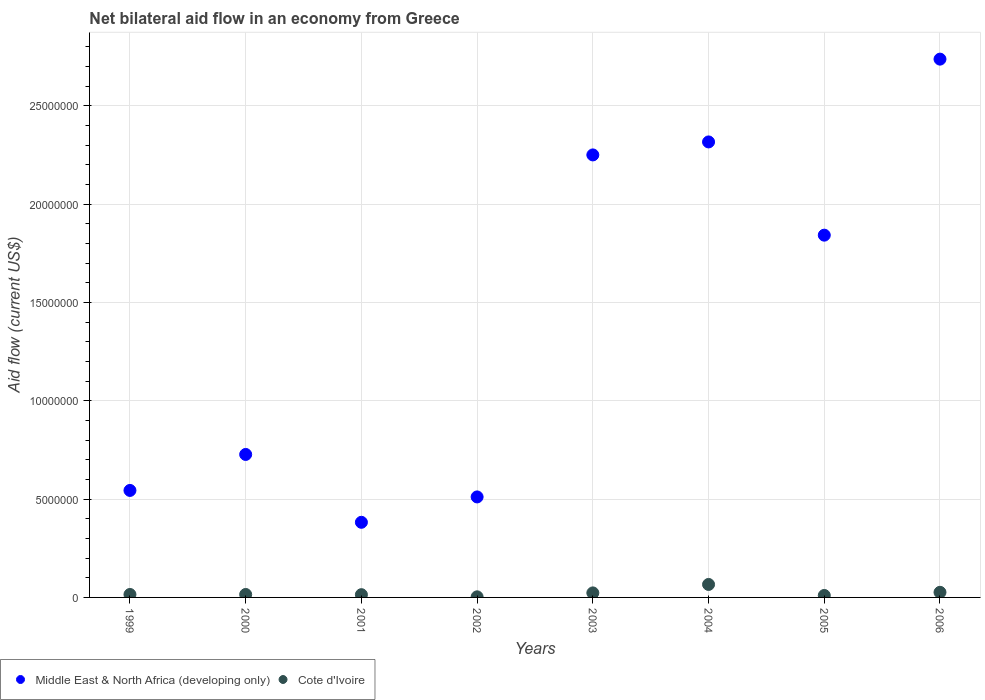How many different coloured dotlines are there?
Your response must be concise. 2. What is the net bilateral aid flow in Cote d'Ivoire in 2001?
Your answer should be very brief. 1.40e+05. Across all years, what is the maximum net bilateral aid flow in Middle East & North Africa (developing only)?
Your answer should be compact. 2.74e+07. Across all years, what is the minimum net bilateral aid flow in Cote d'Ivoire?
Keep it short and to the point. 3.00e+04. What is the total net bilateral aid flow in Cote d'Ivoire in the graph?
Keep it short and to the point. 1.72e+06. What is the difference between the net bilateral aid flow in Middle East & North Africa (developing only) in 2003 and the net bilateral aid flow in Cote d'Ivoire in 1999?
Your response must be concise. 2.24e+07. What is the average net bilateral aid flow in Cote d'Ivoire per year?
Provide a short and direct response. 2.15e+05. In the year 2000, what is the difference between the net bilateral aid flow in Cote d'Ivoire and net bilateral aid flow in Middle East & North Africa (developing only)?
Your answer should be compact. -7.12e+06. What is the ratio of the net bilateral aid flow in Middle East & North Africa (developing only) in 2004 to that in 2005?
Offer a terse response. 1.26. Is the net bilateral aid flow in Middle East & North Africa (developing only) in 1999 less than that in 2000?
Offer a very short reply. Yes. Is the difference between the net bilateral aid flow in Cote d'Ivoire in 2000 and 2003 greater than the difference between the net bilateral aid flow in Middle East & North Africa (developing only) in 2000 and 2003?
Make the answer very short. Yes. What is the difference between the highest and the lowest net bilateral aid flow in Middle East & North Africa (developing only)?
Provide a short and direct response. 2.36e+07. Does the net bilateral aid flow in Cote d'Ivoire monotonically increase over the years?
Keep it short and to the point. No. Is the net bilateral aid flow in Middle East & North Africa (developing only) strictly greater than the net bilateral aid flow in Cote d'Ivoire over the years?
Your answer should be very brief. Yes. Is the net bilateral aid flow in Cote d'Ivoire strictly less than the net bilateral aid flow in Middle East & North Africa (developing only) over the years?
Ensure brevity in your answer.  Yes. How many dotlines are there?
Offer a terse response. 2. What is the difference between two consecutive major ticks on the Y-axis?
Provide a succinct answer. 5.00e+06. Does the graph contain any zero values?
Keep it short and to the point. No. How are the legend labels stacked?
Give a very brief answer. Horizontal. What is the title of the graph?
Offer a terse response. Net bilateral aid flow in an economy from Greece. Does "Sub-Saharan Africa (developing only)" appear as one of the legend labels in the graph?
Provide a succinct answer. No. What is the label or title of the X-axis?
Keep it short and to the point. Years. What is the Aid flow (current US$) of Middle East & North Africa (developing only) in 1999?
Offer a terse response. 5.44e+06. What is the Aid flow (current US$) of Middle East & North Africa (developing only) in 2000?
Provide a short and direct response. 7.27e+06. What is the Aid flow (current US$) in Middle East & North Africa (developing only) in 2001?
Give a very brief answer. 3.82e+06. What is the Aid flow (current US$) of Middle East & North Africa (developing only) in 2002?
Keep it short and to the point. 5.11e+06. What is the Aid flow (current US$) in Cote d'Ivoire in 2002?
Give a very brief answer. 3.00e+04. What is the Aid flow (current US$) of Middle East & North Africa (developing only) in 2003?
Give a very brief answer. 2.25e+07. What is the Aid flow (current US$) of Cote d'Ivoire in 2003?
Your answer should be compact. 2.30e+05. What is the Aid flow (current US$) in Middle East & North Africa (developing only) in 2004?
Your answer should be compact. 2.32e+07. What is the Aid flow (current US$) of Middle East & North Africa (developing only) in 2005?
Your answer should be compact. 1.84e+07. What is the Aid flow (current US$) of Cote d'Ivoire in 2005?
Provide a succinct answer. 1.00e+05. What is the Aid flow (current US$) of Middle East & North Africa (developing only) in 2006?
Your response must be concise. 2.74e+07. Across all years, what is the maximum Aid flow (current US$) in Middle East & North Africa (developing only)?
Offer a terse response. 2.74e+07. Across all years, what is the maximum Aid flow (current US$) in Cote d'Ivoire?
Your answer should be compact. 6.60e+05. Across all years, what is the minimum Aid flow (current US$) in Middle East & North Africa (developing only)?
Your response must be concise. 3.82e+06. What is the total Aid flow (current US$) of Middle East & North Africa (developing only) in the graph?
Give a very brief answer. 1.13e+08. What is the total Aid flow (current US$) in Cote d'Ivoire in the graph?
Keep it short and to the point. 1.72e+06. What is the difference between the Aid flow (current US$) of Middle East & North Africa (developing only) in 1999 and that in 2000?
Keep it short and to the point. -1.83e+06. What is the difference between the Aid flow (current US$) of Cote d'Ivoire in 1999 and that in 2000?
Provide a short and direct response. 0. What is the difference between the Aid flow (current US$) in Middle East & North Africa (developing only) in 1999 and that in 2001?
Provide a short and direct response. 1.62e+06. What is the difference between the Aid flow (current US$) of Cote d'Ivoire in 1999 and that in 2001?
Your answer should be very brief. 10000. What is the difference between the Aid flow (current US$) in Middle East & North Africa (developing only) in 1999 and that in 2002?
Provide a succinct answer. 3.30e+05. What is the difference between the Aid flow (current US$) of Middle East & North Africa (developing only) in 1999 and that in 2003?
Provide a succinct answer. -1.71e+07. What is the difference between the Aid flow (current US$) of Cote d'Ivoire in 1999 and that in 2003?
Keep it short and to the point. -8.00e+04. What is the difference between the Aid flow (current US$) of Middle East & North Africa (developing only) in 1999 and that in 2004?
Provide a succinct answer. -1.77e+07. What is the difference between the Aid flow (current US$) in Cote d'Ivoire in 1999 and that in 2004?
Offer a terse response. -5.10e+05. What is the difference between the Aid flow (current US$) of Middle East & North Africa (developing only) in 1999 and that in 2005?
Ensure brevity in your answer.  -1.30e+07. What is the difference between the Aid flow (current US$) in Cote d'Ivoire in 1999 and that in 2005?
Provide a short and direct response. 5.00e+04. What is the difference between the Aid flow (current US$) in Middle East & North Africa (developing only) in 1999 and that in 2006?
Give a very brief answer. -2.19e+07. What is the difference between the Aid flow (current US$) of Cote d'Ivoire in 1999 and that in 2006?
Offer a terse response. -1.10e+05. What is the difference between the Aid flow (current US$) of Middle East & North Africa (developing only) in 2000 and that in 2001?
Give a very brief answer. 3.45e+06. What is the difference between the Aid flow (current US$) in Middle East & North Africa (developing only) in 2000 and that in 2002?
Offer a very short reply. 2.16e+06. What is the difference between the Aid flow (current US$) of Middle East & North Africa (developing only) in 2000 and that in 2003?
Make the answer very short. -1.52e+07. What is the difference between the Aid flow (current US$) in Middle East & North Africa (developing only) in 2000 and that in 2004?
Offer a terse response. -1.59e+07. What is the difference between the Aid flow (current US$) in Cote d'Ivoire in 2000 and that in 2004?
Provide a succinct answer. -5.10e+05. What is the difference between the Aid flow (current US$) in Middle East & North Africa (developing only) in 2000 and that in 2005?
Provide a succinct answer. -1.12e+07. What is the difference between the Aid flow (current US$) of Middle East & North Africa (developing only) in 2000 and that in 2006?
Offer a terse response. -2.01e+07. What is the difference between the Aid flow (current US$) in Middle East & North Africa (developing only) in 2001 and that in 2002?
Give a very brief answer. -1.29e+06. What is the difference between the Aid flow (current US$) of Cote d'Ivoire in 2001 and that in 2002?
Your response must be concise. 1.10e+05. What is the difference between the Aid flow (current US$) of Middle East & North Africa (developing only) in 2001 and that in 2003?
Make the answer very short. -1.87e+07. What is the difference between the Aid flow (current US$) of Cote d'Ivoire in 2001 and that in 2003?
Give a very brief answer. -9.00e+04. What is the difference between the Aid flow (current US$) of Middle East & North Africa (developing only) in 2001 and that in 2004?
Keep it short and to the point. -1.93e+07. What is the difference between the Aid flow (current US$) in Cote d'Ivoire in 2001 and that in 2004?
Make the answer very short. -5.20e+05. What is the difference between the Aid flow (current US$) of Middle East & North Africa (developing only) in 2001 and that in 2005?
Offer a very short reply. -1.46e+07. What is the difference between the Aid flow (current US$) in Cote d'Ivoire in 2001 and that in 2005?
Ensure brevity in your answer.  4.00e+04. What is the difference between the Aid flow (current US$) of Middle East & North Africa (developing only) in 2001 and that in 2006?
Your answer should be compact. -2.36e+07. What is the difference between the Aid flow (current US$) in Cote d'Ivoire in 2001 and that in 2006?
Your answer should be very brief. -1.20e+05. What is the difference between the Aid flow (current US$) of Middle East & North Africa (developing only) in 2002 and that in 2003?
Keep it short and to the point. -1.74e+07. What is the difference between the Aid flow (current US$) in Cote d'Ivoire in 2002 and that in 2003?
Provide a succinct answer. -2.00e+05. What is the difference between the Aid flow (current US$) of Middle East & North Africa (developing only) in 2002 and that in 2004?
Make the answer very short. -1.80e+07. What is the difference between the Aid flow (current US$) in Cote d'Ivoire in 2002 and that in 2004?
Make the answer very short. -6.30e+05. What is the difference between the Aid flow (current US$) of Middle East & North Africa (developing only) in 2002 and that in 2005?
Provide a succinct answer. -1.33e+07. What is the difference between the Aid flow (current US$) in Cote d'Ivoire in 2002 and that in 2005?
Make the answer very short. -7.00e+04. What is the difference between the Aid flow (current US$) in Middle East & North Africa (developing only) in 2002 and that in 2006?
Your answer should be compact. -2.23e+07. What is the difference between the Aid flow (current US$) in Cote d'Ivoire in 2002 and that in 2006?
Offer a terse response. -2.30e+05. What is the difference between the Aid flow (current US$) of Middle East & North Africa (developing only) in 2003 and that in 2004?
Ensure brevity in your answer.  -6.60e+05. What is the difference between the Aid flow (current US$) of Cote d'Ivoire in 2003 and that in 2004?
Offer a terse response. -4.30e+05. What is the difference between the Aid flow (current US$) in Middle East & North Africa (developing only) in 2003 and that in 2005?
Your response must be concise. 4.08e+06. What is the difference between the Aid flow (current US$) of Middle East & North Africa (developing only) in 2003 and that in 2006?
Keep it short and to the point. -4.87e+06. What is the difference between the Aid flow (current US$) of Cote d'Ivoire in 2003 and that in 2006?
Keep it short and to the point. -3.00e+04. What is the difference between the Aid flow (current US$) of Middle East & North Africa (developing only) in 2004 and that in 2005?
Your response must be concise. 4.74e+06. What is the difference between the Aid flow (current US$) in Cote d'Ivoire in 2004 and that in 2005?
Provide a succinct answer. 5.60e+05. What is the difference between the Aid flow (current US$) in Middle East & North Africa (developing only) in 2004 and that in 2006?
Provide a short and direct response. -4.21e+06. What is the difference between the Aid flow (current US$) of Middle East & North Africa (developing only) in 2005 and that in 2006?
Keep it short and to the point. -8.95e+06. What is the difference between the Aid flow (current US$) in Cote d'Ivoire in 2005 and that in 2006?
Keep it short and to the point. -1.60e+05. What is the difference between the Aid flow (current US$) in Middle East & North Africa (developing only) in 1999 and the Aid flow (current US$) in Cote d'Ivoire in 2000?
Your response must be concise. 5.29e+06. What is the difference between the Aid flow (current US$) in Middle East & North Africa (developing only) in 1999 and the Aid flow (current US$) in Cote d'Ivoire in 2001?
Your answer should be compact. 5.30e+06. What is the difference between the Aid flow (current US$) of Middle East & North Africa (developing only) in 1999 and the Aid flow (current US$) of Cote d'Ivoire in 2002?
Offer a very short reply. 5.41e+06. What is the difference between the Aid flow (current US$) in Middle East & North Africa (developing only) in 1999 and the Aid flow (current US$) in Cote d'Ivoire in 2003?
Your answer should be very brief. 5.21e+06. What is the difference between the Aid flow (current US$) of Middle East & North Africa (developing only) in 1999 and the Aid flow (current US$) of Cote d'Ivoire in 2004?
Give a very brief answer. 4.78e+06. What is the difference between the Aid flow (current US$) in Middle East & North Africa (developing only) in 1999 and the Aid flow (current US$) in Cote d'Ivoire in 2005?
Keep it short and to the point. 5.34e+06. What is the difference between the Aid flow (current US$) in Middle East & North Africa (developing only) in 1999 and the Aid flow (current US$) in Cote d'Ivoire in 2006?
Provide a short and direct response. 5.18e+06. What is the difference between the Aid flow (current US$) of Middle East & North Africa (developing only) in 2000 and the Aid flow (current US$) of Cote d'Ivoire in 2001?
Your answer should be very brief. 7.13e+06. What is the difference between the Aid flow (current US$) in Middle East & North Africa (developing only) in 2000 and the Aid flow (current US$) in Cote d'Ivoire in 2002?
Your answer should be very brief. 7.24e+06. What is the difference between the Aid flow (current US$) in Middle East & North Africa (developing only) in 2000 and the Aid flow (current US$) in Cote d'Ivoire in 2003?
Provide a succinct answer. 7.04e+06. What is the difference between the Aid flow (current US$) of Middle East & North Africa (developing only) in 2000 and the Aid flow (current US$) of Cote d'Ivoire in 2004?
Offer a very short reply. 6.61e+06. What is the difference between the Aid flow (current US$) in Middle East & North Africa (developing only) in 2000 and the Aid flow (current US$) in Cote d'Ivoire in 2005?
Your answer should be very brief. 7.17e+06. What is the difference between the Aid flow (current US$) of Middle East & North Africa (developing only) in 2000 and the Aid flow (current US$) of Cote d'Ivoire in 2006?
Provide a short and direct response. 7.01e+06. What is the difference between the Aid flow (current US$) of Middle East & North Africa (developing only) in 2001 and the Aid flow (current US$) of Cote d'Ivoire in 2002?
Keep it short and to the point. 3.79e+06. What is the difference between the Aid flow (current US$) of Middle East & North Africa (developing only) in 2001 and the Aid flow (current US$) of Cote d'Ivoire in 2003?
Provide a succinct answer. 3.59e+06. What is the difference between the Aid flow (current US$) of Middle East & North Africa (developing only) in 2001 and the Aid flow (current US$) of Cote d'Ivoire in 2004?
Your answer should be compact. 3.16e+06. What is the difference between the Aid flow (current US$) of Middle East & North Africa (developing only) in 2001 and the Aid flow (current US$) of Cote d'Ivoire in 2005?
Your answer should be very brief. 3.72e+06. What is the difference between the Aid flow (current US$) of Middle East & North Africa (developing only) in 2001 and the Aid flow (current US$) of Cote d'Ivoire in 2006?
Provide a short and direct response. 3.56e+06. What is the difference between the Aid flow (current US$) of Middle East & North Africa (developing only) in 2002 and the Aid flow (current US$) of Cote d'Ivoire in 2003?
Your answer should be very brief. 4.88e+06. What is the difference between the Aid flow (current US$) in Middle East & North Africa (developing only) in 2002 and the Aid flow (current US$) in Cote d'Ivoire in 2004?
Your answer should be very brief. 4.45e+06. What is the difference between the Aid flow (current US$) of Middle East & North Africa (developing only) in 2002 and the Aid flow (current US$) of Cote d'Ivoire in 2005?
Offer a very short reply. 5.01e+06. What is the difference between the Aid flow (current US$) in Middle East & North Africa (developing only) in 2002 and the Aid flow (current US$) in Cote d'Ivoire in 2006?
Make the answer very short. 4.85e+06. What is the difference between the Aid flow (current US$) in Middle East & North Africa (developing only) in 2003 and the Aid flow (current US$) in Cote d'Ivoire in 2004?
Keep it short and to the point. 2.18e+07. What is the difference between the Aid flow (current US$) of Middle East & North Africa (developing only) in 2003 and the Aid flow (current US$) of Cote d'Ivoire in 2005?
Ensure brevity in your answer.  2.24e+07. What is the difference between the Aid flow (current US$) of Middle East & North Africa (developing only) in 2003 and the Aid flow (current US$) of Cote d'Ivoire in 2006?
Offer a terse response. 2.22e+07. What is the difference between the Aid flow (current US$) in Middle East & North Africa (developing only) in 2004 and the Aid flow (current US$) in Cote d'Ivoire in 2005?
Offer a very short reply. 2.31e+07. What is the difference between the Aid flow (current US$) of Middle East & North Africa (developing only) in 2004 and the Aid flow (current US$) of Cote d'Ivoire in 2006?
Give a very brief answer. 2.29e+07. What is the difference between the Aid flow (current US$) in Middle East & North Africa (developing only) in 2005 and the Aid flow (current US$) in Cote d'Ivoire in 2006?
Your response must be concise. 1.82e+07. What is the average Aid flow (current US$) of Middle East & North Africa (developing only) per year?
Offer a terse response. 1.41e+07. What is the average Aid flow (current US$) in Cote d'Ivoire per year?
Ensure brevity in your answer.  2.15e+05. In the year 1999, what is the difference between the Aid flow (current US$) of Middle East & North Africa (developing only) and Aid flow (current US$) of Cote d'Ivoire?
Offer a very short reply. 5.29e+06. In the year 2000, what is the difference between the Aid flow (current US$) of Middle East & North Africa (developing only) and Aid flow (current US$) of Cote d'Ivoire?
Keep it short and to the point. 7.12e+06. In the year 2001, what is the difference between the Aid flow (current US$) in Middle East & North Africa (developing only) and Aid flow (current US$) in Cote d'Ivoire?
Keep it short and to the point. 3.68e+06. In the year 2002, what is the difference between the Aid flow (current US$) of Middle East & North Africa (developing only) and Aid flow (current US$) of Cote d'Ivoire?
Offer a terse response. 5.08e+06. In the year 2003, what is the difference between the Aid flow (current US$) in Middle East & North Africa (developing only) and Aid flow (current US$) in Cote d'Ivoire?
Your answer should be compact. 2.23e+07. In the year 2004, what is the difference between the Aid flow (current US$) in Middle East & North Africa (developing only) and Aid flow (current US$) in Cote d'Ivoire?
Keep it short and to the point. 2.25e+07. In the year 2005, what is the difference between the Aid flow (current US$) of Middle East & North Africa (developing only) and Aid flow (current US$) of Cote d'Ivoire?
Your answer should be compact. 1.83e+07. In the year 2006, what is the difference between the Aid flow (current US$) in Middle East & North Africa (developing only) and Aid flow (current US$) in Cote d'Ivoire?
Make the answer very short. 2.71e+07. What is the ratio of the Aid flow (current US$) in Middle East & North Africa (developing only) in 1999 to that in 2000?
Keep it short and to the point. 0.75. What is the ratio of the Aid flow (current US$) in Middle East & North Africa (developing only) in 1999 to that in 2001?
Your response must be concise. 1.42. What is the ratio of the Aid flow (current US$) of Cote d'Ivoire in 1999 to that in 2001?
Keep it short and to the point. 1.07. What is the ratio of the Aid flow (current US$) in Middle East & North Africa (developing only) in 1999 to that in 2002?
Provide a succinct answer. 1.06. What is the ratio of the Aid flow (current US$) in Middle East & North Africa (developing only) in 1999 to that in 2003?
Provide a succinct answer. 0.24. What is the ratio of the Aid flow (current US$) in Cote d'Ivoire in 1999 to that in 2003?
Provide a short and direct response. 0.65. What is the ratio of the Aid flow (current US$) in Middle East & North Africa (developing only) in 1999 to that in 2004?
Offer a very short reply. 0.23. What is the ratio of the Aid flow (current US$) in Cote d'Ivoire in 1999 to that in 2004?
Your answer should be very brief. 0.23. What is the ratio of the Aid flow (current US$) of Middle East & North Africa (developing only) in 1999 to that in 2005?
Keep it short and to the point. 0.3. What is the ratio of the Aid flow (current US$) of Middle East & North Africa (developing only) in 1999 to that in 2006?
Provide a short and direct response. 0.2. What is the ratio of the Aid flow (current US$) of Cote d'Ivoire in 1999 to that in 2006?
Your response must be concise. 0.58. What is the ratio of the Aid flow (current US$) of Middle East & North Africa (developing only) in 2000 to that in 2001?
Provide a short and direct response. 1.9. What is the ratio of the Aid flow (current US$) in Cote d'Ivoire in 2000 to that in 2001?
Your response must be concise. 1.07. What is the ratio of the Aid flow (current US$) of Middle East & North Africa (developing only) in 2000 to that in 2002?
Offer a very short reply. 1.42. What is the ratio of the Aid flow (current US$) of Middle East & North Africa (developing only) in 2000 to that in 2003?
Offer a very short reply. 0.32. What is the ratio of the Aid flow (current US$) in Cote d'Ivoire in 2000 to that in 2003?
Offer a terse response. 0.65. What is the ratio of the Aid flow (current US$) of Middle East & North Africa (developing only) in 2000 to that in 2004?
Ensure brevity in your answer.  0.31. What is the ratio of the Aid flow (current US$) of Cote d'Ivoire in 2000 to that in 2004?
Ensure brevity in your answer.  0.23. What is the ratio of the Aid flow (current US$) of Middle East & North Africa (developing only) in 2000 to that in 2005?
Offer a very short reply. 0.39. What is the ratio of the Aid flow (current US$) of Cote d'Ivoire in 2000 to that in 2005?
Give a very brief answer. 1.5. What is the ratio of the Aid flow (current US$) of Middle East & North Africa (developing only) in 2000 to that in 2006?
Provide a succinct answer. 0.27. What is the ratio of the Aid flow (current US$) of Cote d'Ivoire in 2000 to that in 2006?
Your answer should be very brief. 0.58. What is the ratio of the Aid flow (current US$) of Middle East & North Africa (developing only) in 2001 to that in 2002?
Give a very brief answer. 0.75. What is the ratio of the Aid flow (current US$) of Cote d'Ivoire in 2001 to that in 2002?
Provide a short and direct response. 4.67. What is the ratio of the Aid flow (current US$) in Middle East & North Africa (developing only) in 2001 to that in 2003?
Keep it short and to the point. 0.17. What is the ratio of the Aid flow (current US$) of Cote d'Ivoire in 2001 to that in 2003?
Your response must be concise. 0.61. What is the ratio of the Aid flow (current US$) in Middle East & North Africa (developing only) in 2001 to that in 2004?
Make the answer very short. 0.16. What is the ratio of the Aid flow (current US$) of Cote d'Ivoire in 2001 to that in 2004?
Ensure brevity in your answer.  0.21. What is the ratio of the Aid flow (current US$) in Middle East & North Africa (developing only) in 2001 to that in 2005?
Your answer should be compact. 0.21. What is the ratio of the Aid flow (current US$) in Cote d'Ivoire in 2001 to that in 2005?
Provide a short and direct response. 1.4. What is the ratio of the Aid flow (current US$) of Middle East & North Africa (developing only) in 2001 to that in 2006?
Provide a succinct answer. 0.14. What is the ratio of the Aid flow (current US$) in Cote d'Ivoire in 2001 to that in 2006?
Make the answer very short. 0.54. What is the ratio of the Aid flow (current US$) of Middle East & North Africa (developing only) in 2002 to that in 2003?
Your response must be concise. 0.23. What is the ratio of the Aid flow (current US$) in Cote d'Ivoire in 2002 to that in 2003?
Keep it short and to the point. 0.13. What is the ratio of the Aid flow (current US$) of Middle East & North Africa (developing only) in 2002 to that in 2004?
Give a very brief answer. 0.22. What is the ratio of the Aid flow (current US$) of Cote d'Ivoire in 2002 to that in 2004?
Your answer should be very brief. 0.05. What is the ratio of the Aid flow (current US$) in Middle East & North Africa (developing only) in 2002 to that in 2005?
Your answer should be very brief. 0.28. What is the ratio of the Aid flow (current US$) in Cote d'Ivoire in 2002 to that in 2005?
Your response must be concise. 0.3. What is the ratio of the Aid flow (current US$) of Middle East & North Africa (developing only) in 2002 to that in 2006?
Provide a short and direct response. 0.19. What is the ratio of the Aid flow (current US$) of Cote d'Ivoire in 2002 to that in 2006?
Offer a very short reply. 0.12. What is the ratio of the Aid flow (current US$) of Middle East & North Africa (developing only) in 2003 to that in 2004?
Offer a terse response. 0.97. What is the ratio of the Aid flow (current US$) in Cote d'Ivoire in 2003 to that in 2004?
Offer a very short reply. 0.35. What is the ratio of the Aid flow (current US$) of Middle East & North Africa (developing only) in 2003 to that in 2005?
Ensure brevity in your answer.  1.22. What is the ratio of the Aid flow (current US$) of Cote d'Ivoire in 2003 to that in 2005?
Keep it short and to the point. 2.3. What is the ratio of the Aid flow (current US$) of Middle East & North Africa (developing only) in 2003 to that in 2006?
Your response must be concise. 0.82. What is the ratio of the Aid flow (current US$) of Cote d'Ivoire in 2003 to that in 2006?
Provide a short and direct response. 0.88. What is the ratio of the Aid flow (current US$) in Middle East & North Africa (developing only) in 2004 to that in 2005?
Give a very brief answer. 1.26. What is the ratio of the Aid flow (current US$) of Middle East & North Africa (developing only) in 2004 to that in 2006?
Provide a succinct answer. 0.85. What is the ratio of the Aid flow (current US$) in Cote d'Ivoire in 2004 to that in 2006?
Make the answer very short. 2.54. What is the ratio of the Aid flow (current US$) of Middle East & North Africa (developing only) in 2005 to that in 2006?
Your response must be concise. 0.67. What is the ratio of the Aid flow (current US$) of Cote d'Ivoire in 2005 to that in 2006?
Make the answer very short. 0.38. What is the difference between the highest and the second highest Aid flow (current US$) of Middle East & North Africa (developing only)?
Your answer should be compact. 4.21e+06. What is the difference between the highest and the second highest Aid flow (current US$) of Cote d'Ivoire?
Your answer should be compact. 4.00e+05. What is the difference between the highest and the lowest Aid flow (current US$) in Middle East & North Africa (developing only)?
Ensure brevity in your answer.  2.36e+07. What is the difference between the highest and the lowest Aid flow (current US$) in Cote d'Ivoire?
Offer a terse response. 6.30e+05. 